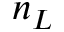<formula> <loc_0><loc_0><loc_500><loc_500>n _ { L }</formula> 